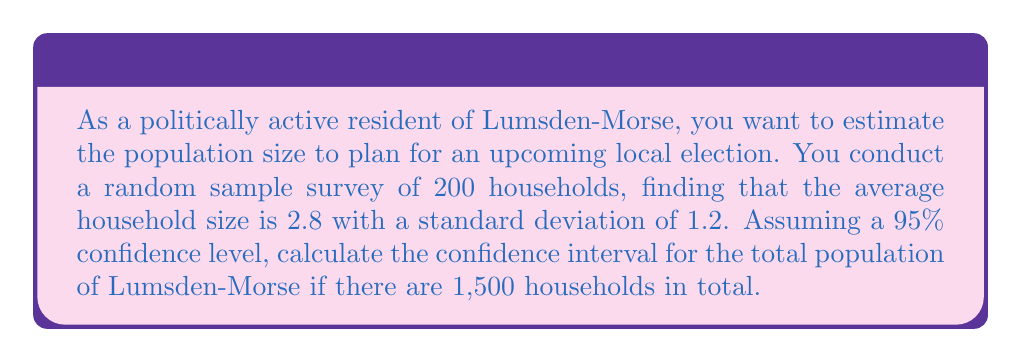Show me your answer to this math problem. Let's approach this step-by-step:

1) We know:
   - Sample size (n) = 200
   - Sample mean (x̄) = 2.8
   - Sample standard deviation (s) = 1.2
   - Total number of households = 1,500
   - Confidence level = 95% (z-score = 1.96)

2) Calculate the standard error (SE) of the mean:
   $$ SE = \frac{s}{\sqrt{n}} = \frac{1.2}{\sqrt{200}} = 0.0849 $$

3) Calculate the margin of error (ME):
   $$ ME = z \times SE = 1.96 \times 0.0849 = 0.1664 $$

4) Calculate the confidence interval for the mean household size:
   $$ CI = \bar{x} \pm ME = 2.8 \pm 0.1664 = (2.6336, 2.9664) $$

5) To estimate the total population, multiply the confidence interval by the total number of households:
   Lower bound: $2.6336 \times 1500 = 3,950.4$
   Upper bound: $2.9664 \times 1500 = 4,449.6$

6) Round to the nearest whole number:
   Estimated population range: (3,950, 4,450)

Therefore, we can say with 95% confidence that the population of Lumsden-Morse is between 3,950 and 4,450 people.
Answer: (3,950, 4,450) 